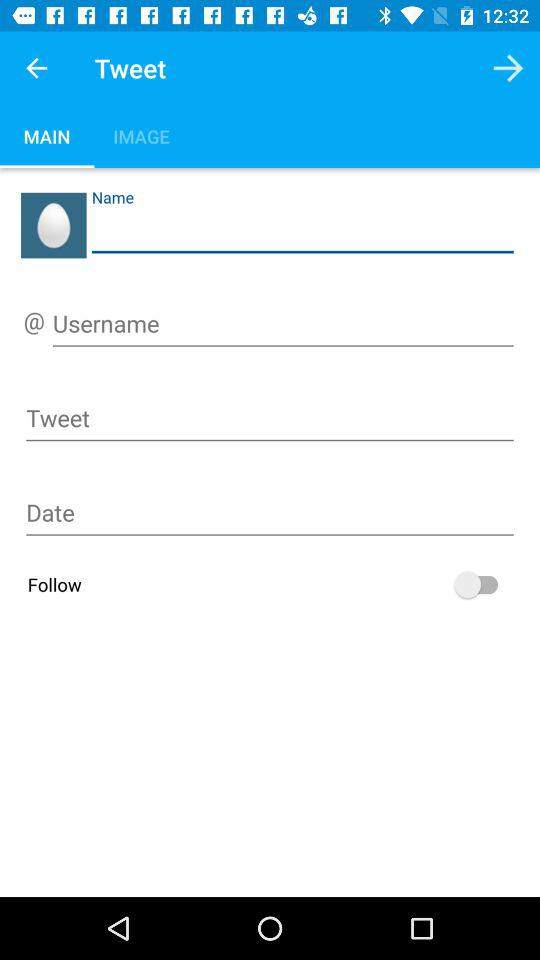What is the status of "Follow"? The status is "off". 